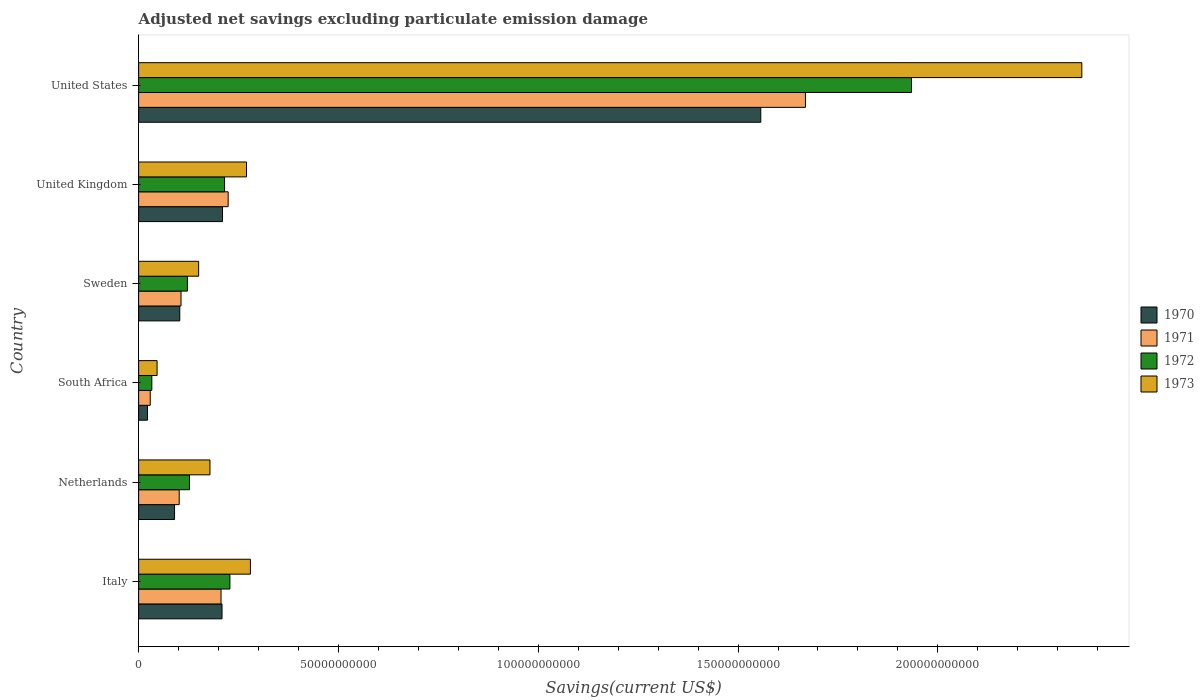How many groups of bars are there?
Your response must be concise. 6. How many bars are there on the 1st tick from the top?
Offer a terse response. 4. How many bars are there on the 1st tick from the bottom?
Give a very brief answer. 4. In how many cases, is the number of bars for a given country not equal to the number of legend labels?
Keep it short and to the point. 0. What is the adjusted net savings in 1970 in South Africa?
Provide a short and direct response. 2.22e+09. Across all countries, what is the maximum adjusted net savings in 1970?
Offer a terse response. 1.56e+11. Across all countries, what is the minimum adjusted net savings in 1973?
Your response must be concise. 4.62e+09. In which country was the adjusted net savings in 1970 minimum?
Provide a succinct answer. South Africa. What is the total adjusted net savings in 1971 in the graph?
Provide a short and direct response. 2.34e+11. What is the difference between the adjusted net savings in 1970 in South Africa and that in United States?
Make the answer very short. -1.53e+11. What is the difference between the adjusted net savings in 1972 in Italy and the adjusted net savings in 1970 in South Africa?
Your answer should be very brief. 2.06e+1. What is the average adjusted net savings in 1971 per country?
Keep it short and to the point. 3.89e+1. What is the difference between the adjusted net savings in 1972 and adjusted net savings in 1971 in United Kingdom?
Your answer should be compact. -9.03e+08. What is the ratio of the adjusted net savings in 1973 in United Kingdom to that in United States?
Your answer should be very brief. 0.11. Is the adjusted net savings in 1971 in South Africa less than that in United States?
Provide a succinct answer. Yes. Is the difference between the adjusted net savings in 1972 in South Africa and United States greater than the difference between the adjusted net savings in 1971 in South Africa and United States?
Provide a succinct answer. No. What is the difference between the highest and the second highest adjusted net savings in 1973?
Make the answer very short. 2.08e+11. What is the difference between the highest and the lowest adjusted net savings in 1970?
Provide a succinct answer. 1.53e+11. In how many countries, is the adjusted net savings in 1971 greater than the average adjusted net savings in 1971 taken over all countries?
Your response must be concise. 1. Is the sum of the adjusted net savings in 1972 in Italy and United Kingdom greater than the maximum adjusted net savings in 1970 across all countries?
Provide a short and direct response. No. Is it the case that in every country, the sum of the adjusted net savings in 1971 and adjusted net savings in 1973 is greater than the sum of adjusted net savings in 1972 and adjusted net savings in 1970?
Your response must be concise. No. Is it the case that in every country, the sum of the adjusted net savings in 1971 and adjusted net savings in 1972 is greater than the adjusted net savings in 1973?
Offer a terse response. Yes. How many bars are there?
Keep it short and to the point. 24. Are all the bars in the graph horizontal?
Your answer should be compact. Yes. How many countries are there in the graph?
Make the answer very short. 6. Does the graph contain grids?
Make the answer very short. No. Where does the legend appear in the graph?
Your answer should be compact. Center right. How many legend labels are there?
Provide a succinct answer. 4. What is the title of the graph?
Provide a succinct answer. Adjusted net savings excluding particulate emission damage. Does "1968" appear as one of the legend labels in the graph?
Ensure brevity in your answer.  No. What is the label or title of the X-axis?
Offer a terse response. Savings(current US$). What is the label or title of the Y-axis?
Ensure brevity in your answer.  Country. What is the Savings(current US$) in 1970 in Italy?
Provide a short and direct response. 2.09e+1. What is the Savings(current US$) in 1971 in Italy?
Ensure brevity in your answer.  2.06e+1. What is the Savings(current US$) in 1972 in Italy?
Your answer should be very brief. 2.28e+1. What is the Savings(current US$) in 1973 in Italy?
Provide a succinct answer. 2.80e+1. What is the Savings(current US$) in 1970 in Netherlands?
Your response must be concise. 8.99e+09. What is the Savings(current US$) in 1971 in Netherlands?
Offer a very short reply. 1.02e+1. What is the Savings(current US$) of 1972 in Netherlands?
Make the answer very short. 1.27e+1. What is the Savings(current US$) of 1973 in Netherlands?
Your answer should be compact. 1.79e+1. What is the Savings(current US$) of 1970 in South Africa?
Ensure brevity in your answer.  2.22e+09. What is the Savings(current US$) of 1971 in South Africa?
Your answer should be compact. 2.90e+09. What is the Savings(current US$) of 1972 in South Africa?
Offer a very short reply. 3.30e+09. What is the Savings(current US$) of 1973 in South Africa?
Your answer should be compact. 4.62e+09. What is the Savings(current US$) in 1970 in Sweden?
Keep it short and to the point. 1.03e+1. What is the Savings(current US$) of 1971 in Sweden?
Ensure brevity in your answer.  1.06e+1. What is the Savings(current US$) of 1972 in Sweden?
Offer a terse response. 1.22e+1. What is the Savings(current US$) of 1973 in Sweden?
Your answer should be compact. 1.50e+1. What is the Savings(current US$) of 1970 in United Kingdom?
Your answer should be compact. 2.10e+1. What is the Savings(current US$) of 1971 in United Kingdom?
Make the answer very short. 2.24e+1. What is the Savings(current US$) in 1972 in United Kingdom?
Your answer should be compact. 2.15e+1. What is the Savings(current US$) of 1973 in United Kingdom?
Keep it short and to the point. 2.70e+1. What is the Savings(current US$) in 1970 in United States?
Your answer should be compact. 1.56e+11. What is the Savings(current US$) of 1971 in United States?
Offer a terse response. 1.67e+11. What is the Savings(current US$) in 1972 in United States?
Make the answer very short. 1.93e+11. What is the Savings(current US$) of 1973 in United States?
Offer a terse response. 2.36e+11. Across all countries, what is the maximum Savings(current US$) in 1970?
Provide a succinct answer. 1.56e+11. Across all countries, what is the maximum Savings(current US$) in 1971?
Provide a succinct answer. 1.67e+11. Across all countries, what is the maximum Savings(current US$) in 1972?
Give a very brief answer. 1.93e+11. Across all countries, what is the maximum Savings(current US$) in 1973?
Ensure brevity in your answer.  2.36e+11. Across all countries, what is the minimum Savings(current US$) in 1970?
Offer a terse response. 2.22e+09. Across all countries, what is the minimum Savings(current US$) in 1971?
Your response must be concise. 2.90e+09. Across all countries, what is the minimum Savings(current US$) of 1972?
Give a very brief answer. 3.30e+09. Across all countries, what is the minimum Savings(current US$) in 1973?
Give a very brief answer. 4.62e+09. What is the total Savings(current US$) of 1970 in the graph?
Provide a short and direct response. 2.19e+11. What is the total Savings(current US$) of 1971 in the graph?
Make the answer very short. 2.34e+11. What is the total Savings(current US$) of 1972 in the graph?
Make the answer very short. 2.66e+11. What is the total Savings(current US$) of 1973 in the graph?
Your answer should be very brief. 3.28e+11. What is the difference between the Savings(current US$) in 1970 in Italy and that in Netherlands?
Keep it short and to the point. 1.19e+1. What is the difference between the Savings(current US$) in 1971 in Italy and that in Netherlands?
Your response must be concise. 1.05e+1. What is the difference between the Savings(current US$) of 1972 in Italy and that in Netherlands?
Ensure brevity in your answer.  1.01e+1. What is the difference between the Savings(current US$) of 1973 in Italy and that in Netherlands?
Provide a succinct answer. 1.01e+1. What is the difference between the Savings(current US$) of 1970 in Italy and that in South Africa?
Keep it short and to the point. 1.87e+1. What is the difference between the Savings(current US$) of 1971 in Italy and that in South Africa?
Offer a very short reply. 1.77e+1. What is the difference between the Savings(current US$) of 1972 in Italy and that in South Africa?
Make the answer very short. 1.95e+1. What is the difference between the Savings(current US$) in 1973 in Italy and that in South Africa?
Make the answer very short. 2.34e+1. What is the difference between the Savings(current US$) in 1970 in Italy and that in Sweden?
Your answer should be very brief. 1.06e+1. What is the difference between the Savings(current US$) in 1971 in Italy and that in Sweden?
Make the answer very short. 1.00e+1. What is the difference between the Savings(current US$) of 1972 in Italy and that in Sweden?
Your answer should be very brief. 1.06e+1. What is the difference between the Savings(current US$) in 1973 in Italy and that in Sweden?
Give a very brief answer. 1.30e+1. What is the difference between the Savings(current US$) of 1970 in Italy and that in United Kingdom?
Offer a terse response. -1.20e+08. What is the difference between the Savings(current US$) of 1971 in Italy and that in United Kingdom?
Provide a short and direct response. -1.78e+09. What is the difference between the Savings(current US$) in 1972 in Italy and that in United Kingdom?
Your answer should be compact. 1.34e+09. What is the difference between the Savings(current US$) in 1973 in Italy and that in United Kingdom?
Offer a very short reply. 9.78e+08. What is the difference between the Savings(current US$) in 1970 in Italy and that in United States?
Provide a short and direct response. -1.35e+11. What is the difference between the Savings(current US$) in 1971 in Italy and that in United States?
Offer a very short reply. -1.46e+11. What is the difference between the Savings(current US$) in 1972 in Italy and that in United States?
Give a very brief answer. -1.71e+11. What is the difference between the Savings(current US$) of 1973 in Italy and that in United States?
Provide a succinct answer. -2.08e+11. What is the difference between the Savings(current US$) of 1970 in Netherlands and that in South Africa?
Provide a short and direct response. 6.77e+09. What is the difference between the Savings(current US$) in 1971 in Netherlands and that in South Africa?
Ensure brevity in your answer.  7.25e+09. What is the difference between the Savings(current US$) of 1972 in Netherlands and that in South Africa?
Your answer should be very brief. 9.43e+09. What is the difference between the Savings(current US$) of 1973 in Netherlands and that in South Africa?
Offer a terse response. 1.32e+1. What is the difference between the Savings(current US$) of 1970 in Netherlands and that in Sweden?
Your response must be concise. -1.31e+09. What is the difference between the Savings(current US$) in 1971 in Netherlands and that in Sweden?
Give a very brief answer. -4.54e+08. What is the difference between the Savings(current US$) in 1972 in Netherlands and that in Sweden?
Give a very brief answer. 5.20e+08. What is the difference between the Savings(current US$) in 1973 in Netherlands and that in Sweden?
Your answer should be compact. 2.83e+09. What is the difference between the Savings(current US$) in 1970 in Netherlands and that in United Kingdom?
Offer a terse response. -1.20e+1. What is the difference between the Savings(current US$) of 1971 in Netherlands and that in United Kingdom?
Ensure brevity in your answer.  -1.22e+1. What is the difference between the Savings(current US$) in 1972 in Netherlands and that in United Kingdom?
Make the answer very short. -8.76e+09. What is the difference between the Savings(current US$) of 1973 in Netherlands and that in United Kingdom?
Give a very brief answer. -9.15e+09. What is the difference between the Savings(current US$) of 1970 in Netherlands and that in United States?
Offer a very short reply. -1.47e+11. What is the difference between the Savings(current US$) in 1971 in Netherlands and that in United States?
Provide a short and direct response. -1.57e+11. What is the difference between the Savings(current US$) in 1972 in Netherlands and that in United States?
Ensure brevity in your answer.  -1.81e+11. What is the difference between the Savings(current US$) of 1973 in Netherlands and that in United States?
Offer a terse response. -2.18e+11. What is the difference between the Savings(current US$) in 1970 in South Africa and that in Sweden?
Offer a very short reply. -8.08e+09. What is the difference between the Savings(current US$) of 1971 in South Africa and that in Sweden?
Make the answer very short. -7.70e+09. What is the difference between the Savings(current US$) in 1972 in South Africa and that in Sweden?
Your answer should be compact. -8.91e+09. What is the difference between the Savings(current US$) of 1973 in South Africa and that in Sweden?
Offer a very short reply. -1.04e+1. What is the difference between the Savings(current US$) of 1970 in South Africa and that in United Kingdom?
Your response must be concise. -1.88e+1. What is the difference between the Savings(current US$) of 1971 in South Africa and that in United Kingdom?
Ensure brevity in your answer.  -1.95e+1. What is the difference between the Savings(current US$) of 1972 in South Africa and that in United Kingdom?
Ensure brevity in your answer.  -1.82e+1. What is the difference between the Savings(current US$) in 1973 in South Africa and that in United Kingdom?
Offer a terse response. -2.24e+1. What is the difference between the Savings(current US$) of 1970 in South Africa and that in United States?
Make the answer very short. -1.53e+11. What is the difference between the Savings(current US$) of 1971 in South Africa and that in United States?
Make the answer very short. -1.64e+11. What is the difference between the Savings(current US$) in 1972 in South Africa and that in United States?
Provide a short and direct response. -1.90e+11. What is the difference between the Savings(current US$) in 1973 in South Africa and that in United States?
Give a very brief answer. -2.31e+11. What is the difference between the Savings(current US$) of 1970 in Sweden and that in United Kingdom?
Offer a terse response. -1.07e+1. What is the difference between the Savings(current US$) of 1971 in Sweden and that in United Kingdom?
Your answer should be very brief. -1.18e+1. What is the difference between the Savings(current US$) in 1972 in Sweden and that in United Kingdom?
Your response must be concise. -9.28e+09. What is the difference between the Savings(current US$) of 1973 in Sweden and that in United Kingdom?
Give a very brief answer. -1.20e+1. What is the difference between the Savings(current US$) in 1970 in Sweden and that in United States?
Your response must be concise. -1.45e+11. What is the difference between the Savings(current US$) of 1971 in Sweden and that in United States?
Offer a very short reply. -1.56e+11. What is the difference between the Savings(current US$) of 1972 in Sweden and that in United States?
Ensure brevity in your answer.  -1.81e+11. What is the difference between the Savings(current US$) in 1973 in Sweden and that in United States?
Offer a terse response. -2.21e+11. What is the difference between the Savings(current US$) in 1970 in United Kingdom and that in United States?
Provide a succinct answer. -1.35e+11. What is the difference between the Savings(current US$) of 1971 in United Kingdom and that in United States?
Your answer should be compact. -1.44e+11. What is the difference between the Savings(current US$) of 1972 in United Kingdom and that in United States?
Your answer should be compact. -1.72e+11. What is the difference between the Savings(current US$) in 1973 in United Kingdom and that in United States?
Give a very brief answer. -2.09e+11. What is the difference between the Savings(current US$) in 1970 in Italy and the Savings(current US$) in 1971 in Netherlands?
Ensure brevity in your answer.  1.07e+1. What is the difference between the Savings(current US$) in 1970 in Italy and the Savings(current US$) in 1972 in Netherlands?
Offer a terse response. 8.14e+09. What is the difference between the Savings(current US$) of 1970 in Italy and the Savings(current US$) of 1973 in Netherlands?
Offer a very short reply. 3.02e+09. What is the difference between the Savings(current US$) of 1971 in Italy and the Savings(current US$) of 1972 in Netherlands?
Give a very brief answer. 7.88e+09. What is the difference between the Savings(current US$) in 1971 in Italy and the Savings(current US$) in 1973 in Netherlands?
Your response must be concise. 2.77e+09. What is the difference between the Savings(current US$) of 1972 in Italy and the Savings(current US$) of 1973 in Netherlands?
Your answer should be very brief. 4.99e+09. What is the difference between the Savings(current US$) of 1970 in Italy and the Savings(current US$) of 1971 in South Africa?
Offer a terse response. 1.80e+1. What is the difference between the Savings(current US$) in 1970 in Italy and the Savings(current US$) in 1972 in South Africa?
Provide a succinct answer. 1.76e+1. What is the difference between the Savings(current US$) in 1970 in Italy and the Savings(current US$) in 1973 in South Africa?
Offer a very short reply. 1.62e+1. What is the difference between the Savings(current US$) in 1971 in Italy and the Savings(current US$) in 1972 in South Africa?
Provide a short and direct response. 1.73e+1. What is the difference between the Savings(current US$) of 1971 in Italy and the Savings(current US$) of 1973 in South Africa?
Ensure brevity in your answer.  1.60e+1. What is the difference between the Savings(current US$) of 1972 in Italy and the Savings(current US$) of 1973 in South Africa?
Keep it short and to the point. 1.82e+1. What is the difference between the Savings(current US$) of 1970 in Italy and the Savings(current US$) of 1971 in Sweden?
Provide a succinct answer. 1.03e+1. What is the difference between the Savings(current US$) of 1970 in Italy and the Savings(current US$) of 1972 in Sweden?
Your response must be concise. 8.66e+09. What is the difference between the Savings(current US$) in 1970 in Italy and the Savings(current US$) in 1973 in Sweden?
Your answer should be compact. 5.85e+09. What is the difference between the Savings(current US$) in 1971 in Italy and the Savings(current US$) in 1972 in Sweden?
Offer a very short reply. 8.40e+09. What is the difference between the Savings(current US$) in 1971 in Italy and the Savings(current US$) in 1973 in Sweden?
Keep it short and to the point. 5.60e+09. What is the difference between the Savings(current US$) of 1972 in Italy and the Savings(current US$) of 1973 in Sweden?
Ensure brevity in your answer.  7.83e+09. What is the difference between the Savings(current US$) of 1970 in Italy and the Savings(current US$) of 1971 in United Kingdom?
Your answer should be very brief. -1.53e+09. What is the difference between the Savings(current US$) in 1970 in Italy and the Savings(current US$) in 1972 in United Kingdom?
Your answer should be very brief. -6.28e+08. What is the difference between the Savings(current US$) of 1970 in Italy and the Savings(current US$) of 1973 in United Kingdom?
Keep it short and to the point. -6.13e+09. What is the difference between the Savings(current US$) of 1971 in Italy and the Savings(current US$) of 1972 in United Kingdom?
Make the answer very short. -8.80e+08. What is the difference between the Savings(current US$) in 1971 in Italy and the Savings(current US$) in 1973 in United Kingdom?
Keep it short and to the point. -6.38e+09. What is the difference between the Savings(current US$) in 1972 in Italy and the Savings(current US$) in 1973 in United Kingdom?
Your answer should be very brief. -4.15e+09. What is the difference between the Savings(current US$) in 1970 in Italy and the Savings(current US$) in 1971 in United States?
Your answer should be compact. -1.46e+11. What is the difference between the Savings(current US$) of 1970 in Italy and the Savings(current US$) of 1972 in United States?
Your response must be concise. -1.73e+11. What is the difference between the Savings(current US$) of 1970 in Italy and the Savings(current US$) of 1973 in United States?
Your answer should be very brief. -2.15e+11. What is the difference between the Savings(current US$) in 1971 in Italy and the Savings(current US$) in 1972 in United States?
Keep it short and to the point. -1.73e+11. What is the difference between the Savings(current US$) of 1971 in Italy and the Savings(current US$) of 1973 in United States?
Your response must be concise. -2.15e+11. What is the difference between the Savings(current US$) of 1972 in Italy and the Savings(current US$) of 1973 in United States?
Your response must be concise. -2.13e+11. What is the difference between the Savings(current US$) of 1970 in Netherlands and the Savings(current US$) of 1971 in South Africa?
Provide a succinct answer. 6.09e+09. What is the difference between the Savings(current US$) in 1970 in Netherlands and the Savings(current US$) in 1972 in South Africa?
Your answer should be compact. 5.69e+09. What is the difference between the Savings(current US$) in 1970 in Netherlands and the Savings(current US$) in 1973 in South Africa?
Offer a very short reply. 4.37e+09. What is the difference between the Savings(current US$) of 1971 in Netherlands and the Savings(current US$) of 1972 in South Africa?
Provide a succinct answer. 6.85e+09. What is the difference between the Savings(current US$) of 1971 in Netherlands and the Savings(current US$) of 1973 in South Africa?
Make the answer very short. 5.53e+09. What is the difference between the Savings(current US$) in 1972 in Netherlands and the Savings(current US$) in 1973 in South Africa?
Your answer should be very brief. 8.11e+09. What is the difference between the Savings(current US$) in 1970 in Netherlands and the Savings(current US$) in 1971 in Sweden?
Your answer should be very brief. -1.62e+09. What is the difference between the Savings(current US$) in 1970 in Netherlands and the Savings(current US$) in 1972 in Sweden?
Offer a very short reply. -3.23e+09. What is the difference between the Savings(current US$) in 1970 in Netherlands and the Savings(current US$) in 1973 in Sweden?
Your answer should be compact. -6.03e+09. What is the difference between the Savings(current US$) of 1971 in Netherlands and the Savings(current US$) of 1972 in Sweden?
Ensure brevity in your answer.  -2.06e+09. What is the difference between the Savings(current US$) in 1971 in Netherlands and the Savings(current US$) in 1973 in Sweden?
Provide a succinct answer. -4.86e+09. What is the difference between the Savings(current US$) in 1972 in Netherlands and the Savings(current US$) in 1973 in Sweden?
Your response must be concise. -2.28e+09. What is the difference between the Savings(current US$) in 1970 in Netherlands and the Savings(current US$) in 1971 in United Kingdom?
Ensure brevity in your answer.  -1.34e+1. What is the difference between the Savings(current US$) in 1970 in Netherlands and the Savings(current US$) in 1972 in United Kingdom?
Give a very brief answer. -1.25e+1. What is the difference between the Savings(current US$) of 1970 in Netherlands and the Savings(current US$) of 1973 in United Kingdom?
Give a very brief answer. -1.80e+1. What is the difference between the Savings(current US$) of 1971 in Netherlands and the Savings(current US$) of 1972 in United Kingdom?
Make the answer very short. -1.13e+1. What is the difference between the Savings(current US$) in 1971 in Netherlands and the Savings(current US$) in 1973 in United Kingdom?
Provide a short and direct response. -1.68e+1. What is the difference between the Savings(current US$) in 1972 in Netherlands and the Savings(current US$) in 1973 in United Kingdom?
Make the answer very short. -1.43e+1. What is the difference between the Savings(current US$) of 1970 in Netherlands and the Savings(current US$) of 1971 in United States?
Give a very brief answer. -1.58e+11. What is the difference between the Savings(current US$) of 1970 in Netherlands and the Savings(current US$) of 1972 in United States?
Your answer should be compact. -1.84e+11. What is the difference between the Savings(current US$) of 1970 in Netherlands and the Savings(current US$) of 1973 in United States?
Provide a succinct answer. -2.27e+11. What is the difference between the Savings(current US$) in 1971 in Netherlands and the Savings(current US$) in 1972 in United States?
Give a very brief answer. -1.83e+11. What is the difference between the Savings(current US$) in 1971 in Netherlands and the Savings(current US$) in 1973 in United States?
Your answer should be compact. -2.26e+11. What is the difference between the Savings(current US$) in 1972 in Netherlands and the Savings(current US$) in 1973 in United States?
Your answer should be compact. -2.23e+11. What is the difference between the Savings(current US$) in 1970 in South Africa and the Savings(current US$) in 1971 in Sweden?
Your answer should be compact. -8.39e+09. What is the difference between the Savings(current US$) of 1970 in South Africa and the Savings(current US$) of 1972 in Sweden?
Offer a terse response. -1.00e+1. What is the difference between the Savings(current US$) in 1970 in South Africa and the Savings(current US$) in 1973 in Sweden?
Make the answer very short. -1.28e+1. What is the difference between the Savings(current US$) of 1971 in South Africa and the Savings(current US$) of 1972 in Sweden?
Ensure brevity in your answer.  -9.31e+09. What is the difference between the Savings(current US$) in 1971 in South Africa and the Savings(current US$) in 1973 in Sweden?
Keep it short and to the point. -1.21e+1. What is the difference between the Savings(current US$) in 1972 in South Africa and the Savings(current US$) in 1973 in Sweden?
Your answer should be compact. -1.17e+1. What is the difference between the Savings(current US$) in 1970 in South Africa and the Savings(current US$) in 1971 in United Kingdom?
Your response must be concise. -2.02e+1. What is the difference between the Savings(current US$) of 1970 in South Africa and the Savings(current US$) of 1972 in United Kingdom?
Offer a very short reply. -1.93e+1. What is the difference between the Savings(current US$) in 1970 in South Africa and the Savings(current US$) in 1973 in United Kingdom?
Keep it short and to the point. -2.48e+1. What is the difference between the Savings(current US$) of 1971 in South Africa and the Savings(current US$) of 1972 in United Kingdom?
Make the answer very short. -1.86e+1. What is the difference between the Savings(current US$) of 1971 in South Africa and the Savings(current US$) of 1973 in United Kingdom?
Your response must be concise. -2.41e+1. What is the difference between the Savings(current US$) of 1972 in South Africa and the Savings(current US$) of 1973 in United Kingdom?
Make the answer very short. -2.37e+1. What is the difference between the Savings(current US$) of 1970 in South Africa and the Savings(current US$) of 1971 in United States?
Give a very brief answer. -1.65e+11. What is the difference between the Savings(current US$) in 1970 in South Africa and the Savings(current US$) in 1972 in United States?
Your answer should be compact. -1.91e+11. What is the difference between the Savings(current US$) of 1970 in South Africa and the Savings(current US$) of 1973 in United States?
Provide a short and direct response. -2.34e+11. What is the difference between the Savings(current US$) of 1971 in South Africa and the Savings(current US$) of 1972 in United States?
Make the answer very short. -1.91e+11. What is the difference between the Savings(current US$) in 1971 in South Africa and the Savings(current US$) in 1973 in United States?
Provide a succinct answer. -2.33e+11. What is the difference between the Savings(current US$) in 1972 in South Africa and the Savings(current US$) in 1973 in United States?
Your answer should be compact. -2.33e+11. What is the difference between the Savings(current US$) of 1970 in Sweden and the Savings(current US$) of 1971 in United Kingdom?
Offer a very short reply. -1.21e+1. What is the difference between the Savings(current US$) of 1970 in Sweden and the Savings(current US$) of 1972 in United Kingdom?
Make the answer very short. -1.12e+1. What is the difference between the Savings(current US$) of 1970 in Sweden and the Savings(current US$) of 1973 in United Kingdom?
Keep it short and to the point. -1.67e+1. What is the difference between the Savings(current US$) of 1971 in Sweden and the Savings(current US$) of 1972 in United Kingdom?
Provide a succinct answer. -1.09e+1. What is the difference between the Savings(current US$) of 1971 in Sweden and the Savings(current US$) of 1973 in United Kingdom?
Make the answer very short. -1.64e+1. What is the difference between the Savings(current US$) of 1972 in Sweden and the Savings(current US$) of 1973 in United Kingdom?
Provide a short and direct response. -1.48e+1. What is the difference between the Savings(current US$) in 1970 in Sweden and the Savings(current US$) in 1971 in United States?
Your answer should be compact. -1.57e+11. What is the difference between the Savings(current US$) of 1970 in Sweden and the Savings(current US$) of 1972 in United States?
Offer a terse response. -1.83e+11. What is the difference between the Savings(current US$) in 1970 in Sweden and the Savings(current US$) in 1973 in United States?
Make the answer very short. -2.26e+11. What is the difference between the Savings(current US$) of 1971 in Sweden and the Savings(current US$) of 1972 in United States?
Offer a terse response. -1.83e+11. What is the difference between the Savings(current US$) of 1971 in Sweden and the Savings(current US$) of 1973 in United States?
Make the answer very short. -2.25e+11. What is the difference between the Savings(current US$) in 1972 in Sweden and the Savings(current US$) in 1973 in United States?
Give a very brief answer. -2.24e+11. What is the difference between the Savings(current US$) of 1970 in United Kingdom and the Savings(current US$) of 1971 in United States?
Ensure brevity in your answer.  -1.46e+11. What is the difference between the Savings(current US$) of 1970 in United Kingdom and the Savings(current US$) of 1972 in United States?
Make the answer very short. -1.72e+11. What is the difference between the Savings(current US$) of 1970 in United Kingdom and the Savings(current US$) of 1973 in United States?
Your answer should be very brief. -2.15e+11. What is the difference between the Savings(current US$) in 1971 in United Kingdom and the Savings(current US$) in 1972 in United States?
Your answer should be compact. -1.71e+11. What is the difference between the Savings(current US$) in 1971 in United Kingdom and the Savings(current US$) in 1973 in United States?
Your answer should be very brief. -2.14e+11. What is the difference between the Savings(current US$) of 1972 in United Kingdom and the Savings(current US$) of 1973 in United States?
Ensure brevity in your answer.  -2.15e+11. What is the average Savings(current US$) in 1970 per country?
Provide a succinct answer. 3.65e+1. What is the average Savings(current US$) of 1971 per country?
Offer a very short reply. 3.89e+1. What is the average Savings(current US$) in 1972 per country?
Make the answer very short. 4.43e+1. What is the average Savings(current US$) of 1973 per country?
Give a very brief answer. 5.47e+1. What is the difference between the Savings(current US$) in 1970 and Savings(current US$) in 1971 in Italy?
Offer a very short reply. 2.53e+08. What is the difference between the Savings(current US$) in 1970 and Savings(current US$) in 1972 in Italy?
Give a very brief answer. -1.97e+09. What is the difference between the Savings(current US$) in 1970 and Savings(current US$) in 1973 in Italy?
Ensure brevity in your answer.  -7.11e+09. What is the difference between the Savings(current US$) of 1971 and Savings(current US$) of 1972 in Italy?
Give a very brief answer. -2.23e+09. What is the difference between the Savings(current US$) of 1971 and Savings(current US$) of 1973 in Italy?
Offer a very short reply. -7.36e+09. What is the difference between the Savings(current US$) of 1972 and Savings(current US$) of 1973 in Italy?
Your answer should be very brief. -5.13e+09. What is the difference between the Savings(current US$) in 1970 and Savings(current US$) in 1971 in Netherlands?
Keep it short and to the point. -1.17e+09. What is the difference between the Savings(current US$) of 1970 and Savings(current US$) of 1972 in Netherlands?
Offer a terse response. -3.75e+09. What is the difference between the Savings(current US$) in 1970 and Savings(current US$) in 1973 in Netherlands?
Your answer should be compact. -8.86e+09. What is the difference between the Savings(current US$) in 1971 and Savings(current US$) in 1972 in Netherlands?
Keep it short and to the point. -2.58e+09. What is the difference between the Savings(current US$) of 1971 and Savings(current US$) of 1973 in Netherlands?
Ensure brevity in your answer.  -7.70e+09. What is the difference between the Savings(current US$) in 1972 and Savings(current US$) in 1973 in Netherlands?
Make the answer very short. -5.11e+09. What is the difference between the Savings(current US$) in 1970 and Savings(current US$) in 1971 in South Africa?
Offer a terse response. -6.85e+08. What is the difference between the Savings(current US$) in 1970 and Savings(current US$) in 1972 in South Africa?
Your response must be concise. -1.08e+09. What is the difference between the Savings(current US$) of 1970 and Savings(current US$) of 1973 in South Africa?
Give a very brief answer. -2.40e+09. What is the difference between the Savings(current US$) in 1971 and Savings(current US$) in 1972 in South Africa?
Ensure brevity in your answer.  -4.00e+08. What is the difference between the Savings(current US$) of 1971 and Savings(current US$) of 1973 in South Africa?
Provide a succinct answer. -1.72e+09. What is the difference between the Savings(current US$) in 1972 and Savings(current US$) in 1973 in South Africa?
Your response must be concise. -1.32e+09. What is the difference between the Savings(current US$) of 1970 and Savings(current US$) of 1971 in Sweden?
Your answer should be very brief. -3.10e+08. What is the difference between the Savings(current US$) of 1970 and Savings(current US$) of 1972 in Sweden?
Your answer should be compact. -1.92e+09. What is the difference between the Savings(current US$) in 1970 and Savings(current US$) in 1973 in Sweden?
Your response must be concise. -4.72e+09. What is the difference between the Savings(current US$) in 1971 and Savings(current US$) in 1972 in Sweden?
Your answer should be very brief. -1.61e+09. What is the difference between the Savings(current US$) of 1971 and Savings(current US$) of 1973 in Sweden?
Your answer should be compact. -4.41e+09. What is the difference between the Savings(current US$) of 1972 and Savings(current US$) of 1973 in Sweden?
Provide a short and direct response. -2.80e+09. What is the difference between the Savings(current US$) of 1970 and Savings(current US$) of 1971 in United Kingdom?
Make the answer very short. -1.41e+09. What is the difference between the Savings(current US$) of 1970 and Savings(current US$) of 1972 in United Kingdom?
Your answer should be compact. -5.08e+08. What is the difference between the Savings(current US$) of 1970 and Savings(current US$) of 1973 in United Kingdom?
Make the answer very short. -6.01e+09. What is the difference between the Savings(current US$) in 1971 and Savings(current US$) in 1972 in United Kingdom?
Offer a terse response. 9.03e+08. What is the difference between the Savings(current US$) of 1971 and Savings(current US$) of 1973 in United Kingdom?
Give a very brief answer. -4.60e+09. What is the difference between the Savings(current US$) of 1972 and Savings(current US$) of 1973 in United Kingdom?
Ensure brevity in your answer.  -5.50e+09. What is the difference between the Savings(current US$) in 1970 and Savings(current US$) in 1971 in United States?
Give a very brief answer. -1.12e+1. What is the difference between the Savings(current US$) in 1970 and Savings(current US$) in 1972 in United States?
Give a very brief answer. -3.77e+1. What is the difference between the Savings(current US$) in 1970 and Savings(current US$) in 1973 in United States?
Your answer should be very brief. -8.03e+1. What is the difference between the Savings(current US$) in 1971 and Savings(current US$) in 1972 in United States?
Your response must be concise. -2.65e+1. What is the difference between the Savings(current US$) in 1971 and Savings(current US$) in 1973 in United States?
Make the answer very short. -6.92e+1. What is the difference between the Savings(current US$) of 1972 and Savings(current US$) of 1973 in United States?
Make the answer very short. -4.26e+1. What is the ratio of the Savings(current US$) of 1970 in Italy to that in Netherlands?
Give a very brief answer. 2.32. What is the ratio of the Savings(current US$) in 1971 in Italy to that in Netherlands?
Your answer should be very brief. 2.03. What is the ratio of the Savings(current US$) of 1972 in Italy to that in Netherlands?
Provide a succinct answer. 1.79. What is the ratio of the Savings(current US$) of 1973 in Italy to that in Netherlands?
Give a very brief answer. 1.57. What is the ratio of the Savings(current US$) of 1970 in Italy to that in South Africa?
Give a very brief answer. 9.41. What is the ratio of the Savings(current US$) of 1971 in Italy to that in South Africa?
Make the answer very short. 7.1. What is the ratio of the Savings(current US$) in 1972 in Italy to that in South Africa?
Your answer should be very brief. 6.92. What is the ratio of the Savings(current US$) of 1973 in Italy to that in South Africa?
Ensure brevity in your answer.  6.05. What is the ratio of the Savings(current US$) of 1970 in Italy to that in Sweden?
Offer a very short reply. 2.03. What is the ratio of the Savings(current US$) of 1971 in Italy to that in Sweden?
Ensure brevity in your answer.  1.94. What is the ratio of the Savings(current US$) in 1972 in Italy to that in Sweden?
Your answer should be compact. 1.87. What is the ratio of the Savings(current US$) of 1973 in Italy to that in Sweden?
Your answer should be very brief. 1.86. What is the ratio of the Savings(current US$) in 1971 in Italy to that in United Kingdom?
Make the answer very short. 0.92. What is the ratio of the Savings(current US$) in 1972 in Italy to that in United Kingdom?
Keep it short and to the point. 1.06. What is the ratio of the Savings(current US$) in 1973 in Italy to that in United Kingdom?
Give a very brief answer. 1.04. What is the ratio of the Savings(current US$) of 1970 in Italy to that in United States?
Give a very brief answer. 0.13. What is the ratio of the Savings(current US$) in 1971 in Italy to that in United States?
Offer a terse response. 0.12. What is the ratio of the Savings(current US$) in 1972 in Italy to that in United States?
Give a very brief answer. 0.12. What is the ratio of the Savings(current US$) of 1973 in Italy to that in United States?
Your response must be concise. 0.12. What is the ratio of the Savings(current US$) of 1970 in Netherlands to that in South Africa?
Provide a short and direct response. 4.05. What is the ratio of the Savings(current US$) in 1971 in Netherlands to that in South Africa?
Your answer should be compact. 3.5. What is the ratio of the Savings(current US$) in 1972 in Netherlands to that in South Africa?
Ensure brevity in your answer.  3.86. What is the ratio of the Savings(current US$) of 1973 in Netherlands to that in South Africa?
Ensure brevity in your answer.  3.86. What is the ratio of the Savings(current US$) in 1970 in Netherlands to that in Sweden?
Your response must be concise. 0.87. What is the ratio of the Savings(current US$) in 1971 in Netherlands to that in Sweden?
Your answer should be very brief. 0.96. What is the ratio of the Savings(current US$) in 1972 in Netherlands to that in Sweden?
Provide a succinct answer. 1.04. What is the ratio of the Savings(current US$) in 1973 in Netherlands to that in Sweden?
Ensure brevity in your answer.  1.19. What is the ratio of the Savings(current US$) in 1970 in Netherlands to that in United Kingdom?
Your response must be concise. 0.43. What is the ratio of the Savings(current US$) of 1971 in Netherlands to that in United Kingdom?
Offer a very short reply. 0.45. What is the ratio of the Savings(current US$) of 1972 in Netherlands to that in United Kingdom?
Provide a succinct answer. 0.59. What is the ratio of the Savings(current US$) of 1973 in Netherlands to that in United Kingdom?
Ensure brevity in your answer.  0.66. What is the ratio of the Savings(current US$) of 1970 in Netherlands to that in United States?
Provide a succinct answer. 0.06. What is the ratio of the Savings(current US$) of 1971 in Netherlands to that in United States?
Make the answer very short. 0.06. What is the ratio of the Savings(current US$) of 1972 in Netherlands to that in United States?
Ensure brevity in your answer.  0.07. What is the ratio of the Savings(current US$) in 1973 in Netherlands to that in United States?
Provide a short and direct response. 0.08. What is the ratio of the Savings(current US$) of 1970 in South Africa to that in Sweden?
Give a very brief answer. 0.22. What is the ratio of the Savings(current US$) in 1971 in South Africa to that in Sweden?
Give a very brief answer. 0.27. What is the ratio of the Savings(current US$) of 1972 in South Africa to that in Sweden?
Make the answer very short. 0.27. What is the ratio of the Savings(current US$) of 1973 in South Africa to that in Sweden?
Your answer should be compact. 0.31. What is the ratio of the Savings(current US$) of 1970 in South Africa to that in United Kingdom?
Your answer should be compact. 0.11. What is the ratio of the Savings(current US$) of 1971 in South Africa to that in United Kingdom?
Provide a short and direct response. 0.13. What is the ratio of the Savings(current US$) in 1972 in South Africa to that in United Kingdom?
Keep it short and to the point. 0.15. What is the ratio of the Savings(current US$) in 1973 in South Africa to that in United Kingdom?
Offer a very short reply. 0.17. What is the ratio of the Savings(current US$) in 1970 in South Africa to that in United States?
Provide a short and direct response. 0.01. What is the ratio of the Savings(current US$) in 1971 in South Africa to that in United States?
Your answer should be compact. 0.02. What is the ratio of the Savings(current US$) of 1972 in South Africa to that in United States?
Give a very brief answer. 0.02. What is the ratio of the Savings(current US$) of 1973 in South Africa to that in United States?
Your response must be concise. 0.02. What is the ratio of the Savings(current US$) of 1970 in Sweden to that in United Kingdom?
Offer a terse response. 0.49. What is the ratio of the Savings(current US$) of 1971 in Sweden to that in United Kingdom?
Ensure brevity in your answer.  0.47. What is the ratio of the Savings(current US$) of 1972 in Sweden to that in United Kingdom?
Provide a short and direct response. 0.57. What is the ratio of the Savings(current US$) of 1973 in Sweden to that in United Kingdom?
Offer a very short reply. 0.56. What is the ratio of the Savings(current US$) of 1970 in Sweden to that in United States?
Offer a terse response. 0.07. What is the ratio of the Savings(current US$) in 1971 in Sweden to that in United States?
Make the answer very short. 0.06. What is the ratio of the Savings(current US$) of 1972 in Sweden to that in United States?
Give a very brief answer. 0.06. What is the ratio of the Savings(current US$) of 1973 in Sweden to that in United States?
Provide a short and direct response. 0.06. What is the ratio of the Savings(current US$) in 1970 in United Kingdom to that in United States?
Offer a very short reply. 0.13. What is the ratio of the Savings(current US$) of 1971 in United Kingdom to that in United States?
Give a very brief answer. 0.13. What is the ratio of the Savings(current US$) of 1972 in United Kingdom to that in United States?
Provide a succinct answer. 0.11. What is the ratio of the Savings(current US$) of 1973 in United Kingdom to that in United States?
Offer a terse response. 0.11. What is the difference between the highest and the second highest Savings(current US$) of 1970?
Keep it short and to the point. 1.35e+11. What is the difference between the highest and the second highest Savings(current US$) of 1971?
Your answer should be compact. 1.44e+11. What is the difference between the highest and the second highest Savings(current US$) in 1972?
Your answer should be very brief. 1.71e+11. What is the difference between the highest and the second highest Savings(current US$) in 1973?
Your response must be concise. 2.08e+11. What is the difference between the highest and the lowest Savings(current US$) in 1970?
Make the answer very short. 1.53e+11. What is the difference between the highest and the lowest Savings(current US$) of 1971?
Your answer should be very brief. 1.64e+11. What is the difference between the highest and the lowest Savings(current US$) of 1972?
Give a very brief answer. 1.90e+11. What is the difference between the highest and the lowest Savings(current US$) of 1973?
Offer a terse response. 2.31e+11. 